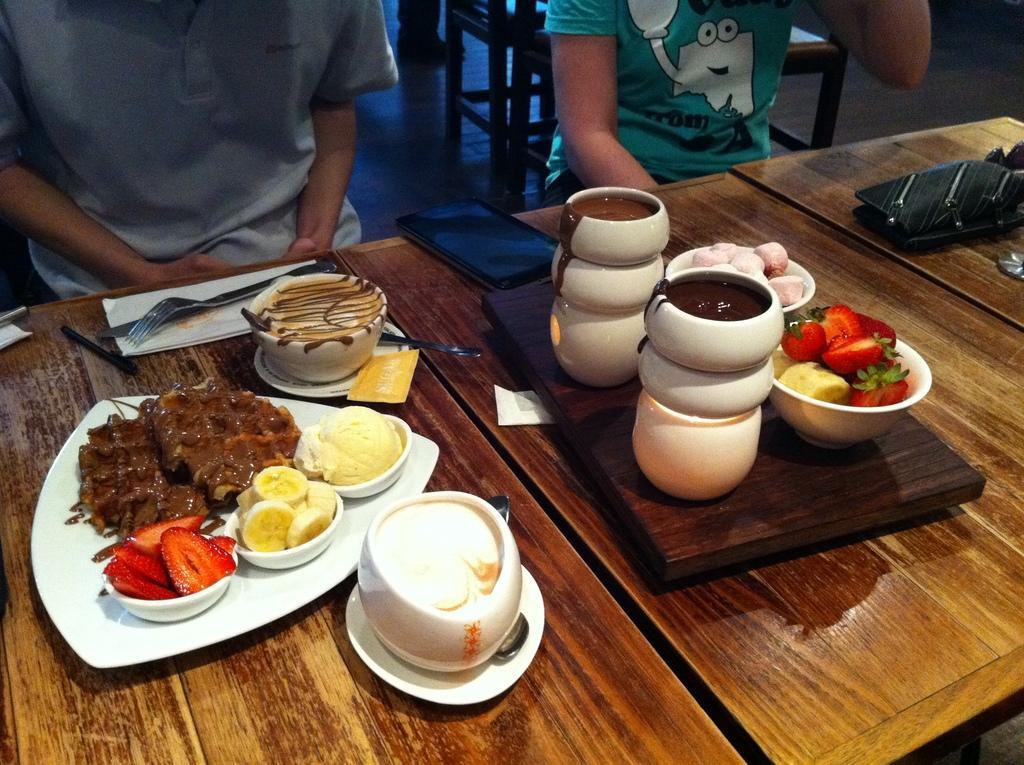In one or two sentences, can you explain what this image depicts? In this image there is a table and we can see bowls, plate, mug, saucer, fork, spoon, napkin, tray and some food placed on the table and we can see a tablet. In the background there are people sitting and there are chairs. 